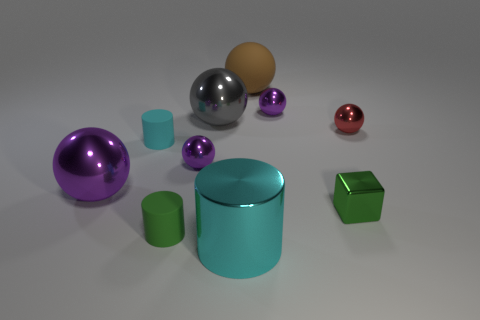Are there more small green cylinders than purple metal spheres?
Provide a succinct answer. No. How many objects are metallic things that are right of the big purple shiny sphere or purple metallic balls that are to the right of the cyan rubber cylinder?
Provide a succinct answer. 6. What is the color of the rubber thing that is the same size as the gray shiny ball?
Offer a very short reply. Brown. Is the small red sphere made of the same material as the green cylinder?
Offer a very short reply. No. What is the material of the tiny cylinder that is behind the metal thing that is left of the small cyan cylinder?
Give a very brief answer. Rubber. Is the number of large things behind the cyan metal cylinder greater than the number of large gray shiny balls?
Ensure brevity in your answer.  Yes. How many other objects are there of the same size as the brown thing?
Keep it short and to the point. 3. What is the color of the small cylinder that is in front of the tiny purple sphere in front of the red object in front of the large gray thing?
Provide a succinct answer. Green. What number of tiny purple things are in front of the cyan object on the left side of the cyan cylinder that is on the right side of the gray sphere?
Offer a very short reply. 1. Are there any other things of the same color as the matte sphere?
Your answer should be compact. No. 